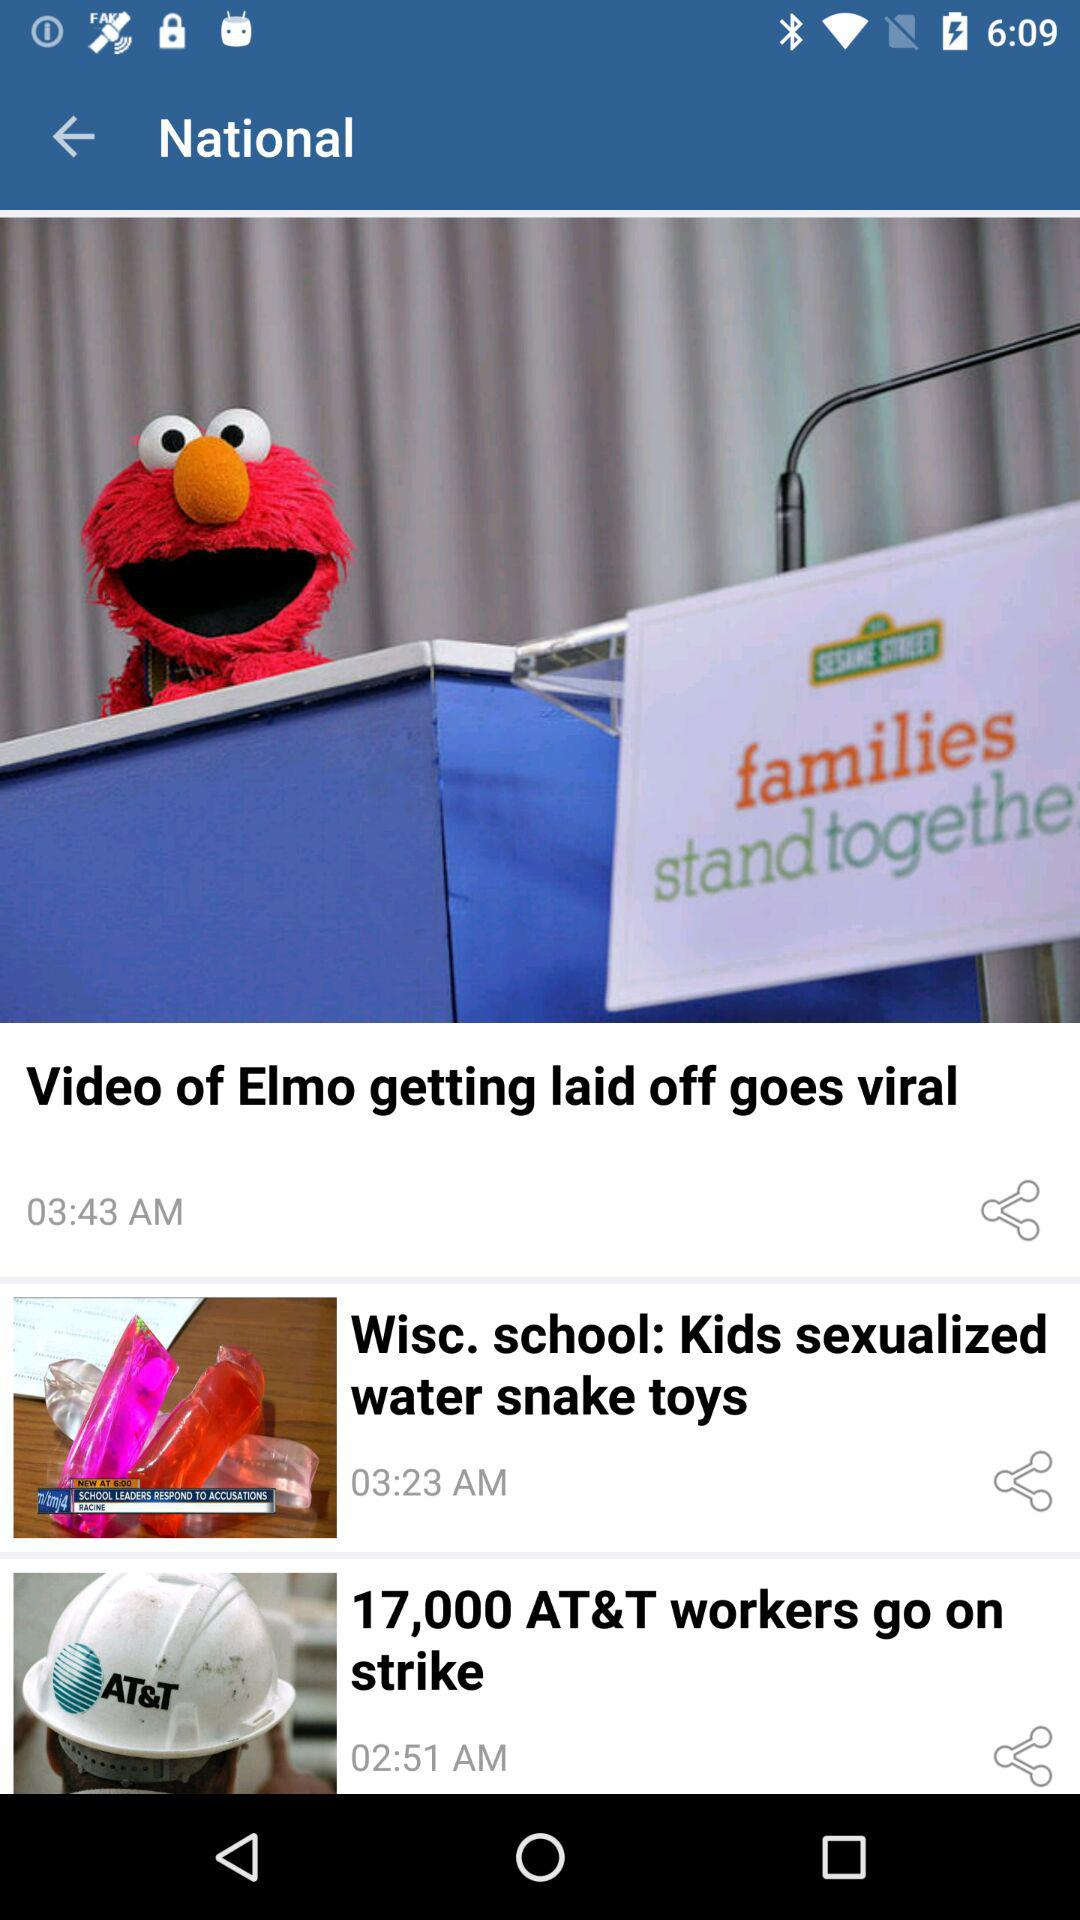Which video was posted at 2:51 am? The video "17,000 AT&T workers go on strike" was posted at 2:51 am. 